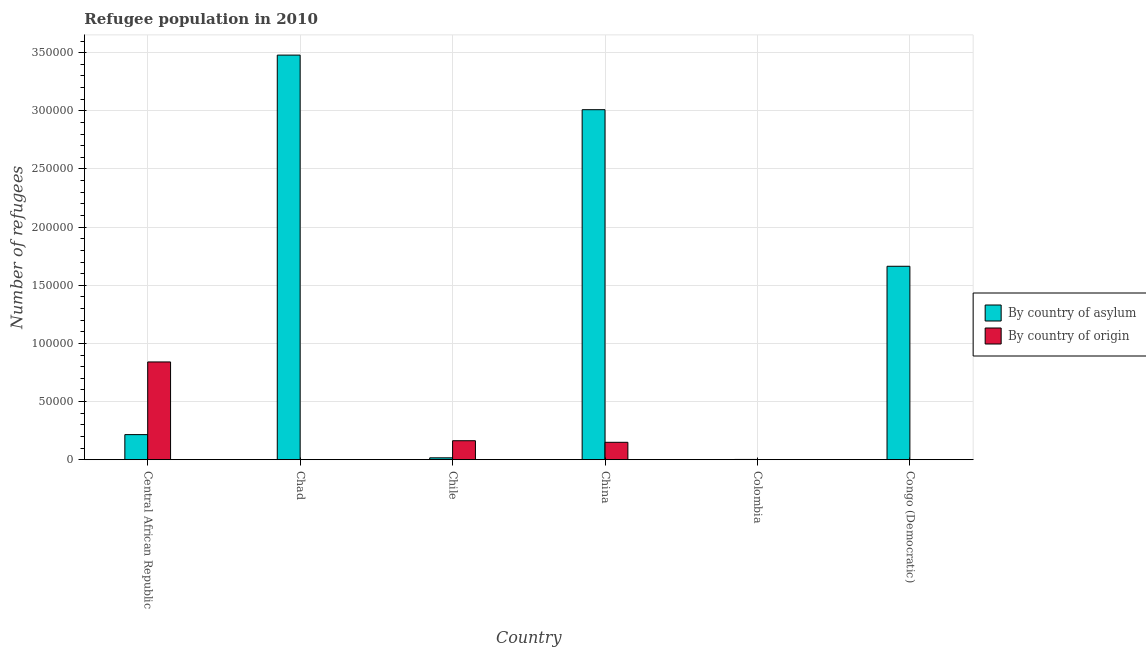How many different coloured bars are there?
Give a very brief answer. 2. What is the label of the 6th group of bars from the left?
Provide a succinct answer. Congo (Democratic). In how many cases, is the number of bars for a given country not equal to the number of legend labels?
Make the answer very short. 0. What is the number of refugees by country of asylum in China?
Your answer should be compact. 3.01e+05. Across all countries, what is the maximum number of refugees by country of asylum?
Your answer should be compact. 3.48e+05. Across all countries, what is the minimum number of refugees by country of asylum?
Your answer should be compact. 212. In which country was the number of refugees by country of origin maximum?
Offer a very short reply. Central African Republic. In which country was the number of refugees by country of origin minimum?
Offer a very short reply. Congo (Democratic). What is the total number of refugees by country of asylum in the graph?
Your answer should be very brief. 8.39e+05. What is the difference between the number of refugees by country of origin in Central African Republic and that in Chad?
Give a very brief answer. 8.40e+04. What is the difference between the number of refugees by country of asylum in China and the number of refugees by country of origin in Chad?
Offer a very short reply. 3.01e+05. What is the average number of refugees by country of origin per country?
Your answer should be compact. 1.92e+04. What is the difference between the number of refugees by country of origin and number of refugees by country of asylum in Colombia?
Give a very brief answer. -122. In how many countries, is the number of refugees by country of asylum greater than 340000 ?
Offer a terse response. 1. What is the ratio of the number of refugees by country of asylum in Central African Republic to that in Congo (Democratic)?
Your answer should be very brief. 0.13. Is the number of refugees by country of origin in Central African Republic less than that in Chad?
Provide a succinct answer. No. Is the difference between the number of refugees by country of asylum in Chad and China greater than the difference between the number of refugees by country of origin in Chad and China?
Give a very brief answer. Yes. What is the difference between the highest and the second highest number of refugees by country of asylum?
Offer a terse response. 4.70e+04. What is the difference between the highest and the lowest number of refugees by country of origin?
Your answer should be compact. 8.41e+04. In how many countries, is the number of refugees by country of asylum greater than the average number of refugees by country of asylum taken over all countries?
Make the answer very short. 3. What does the 1st bar from the left in Colombia represents?
Ensure brevity in your answer.  By country of asylum. What does the 2nd bar from the right in Chad represents?
Provide a short and direct response. By country of asylum. How many bars are there?
Your answer should be very brief. 12. What is the difference between two consecutive major ticks on the Y-axis?
Provide a short and direct response. 5.00e+04. How many legend labels are there?
Your response must be concise. 2. How are the legend labels stacked?
Give a very brief answer. Vertical. What is the title of the graph?
Provide a short and direct response. Refugee population in 2010. Does "Official aid received" appear as one of the legend labels in the graph?
Offer a terse response. No. What is the label or title of the X-axis?
Make the answer very short. Country. What is the label or title of the Y-axis?
Keep it short and to the point. Number of refugees. What is the Number of refugees of By country of asylum in Central African Republic?
Provide a succinct answer. 2.16e+04. What is the Number of refugees of By country of origin in Central African Republic?
Offer a terse response. 8.41e+04. What is the Number of refugees of By country of asylum in Chad?
Offer a terse response. 3.48e+05. What is the Number of refugees in By country of origin in Chad?
Make the answer very short. 25. What is the Number of refugees of By country of asylum in Chile?
Offer a very short reply. 1621. What is the Number of refugees in By country of origin in Chile?
Keep it short and to the point. 1.63e+04. What is the Number of refugees in By country of asylum in China?
Offer a very short reply. 3.01e+05. What is the Number of refugees in By country of origin in China?
Ensure brevity in your answer.  1.50e+04. What is the Number of refugees in By country of asylum in Colombia?
Keep it short and to the point. 212. What is the Number of refugees in By country of asylum in Congo (Democratic)?
Ensure brevity in your answer.  1.66e+05. What is the Number of refugees of By country of origin in Congo (Democratic)?
Provide a succinct answer. 1. Across all countries, what is the maximum Number of refugees in By country of asylum?
Provide a succinct answer. 3.48e+05. Across all countries, what is the maximum Number of refugees of By country of origin?
Offer a very short reply. 8.41e+04. Across all countries, what is the minimum Number of refugees of By country of asylum?
Provide a succinct answer. 212. Across all countries, what is the minimum Number of refugees of By country of origin?
Keep it short and to the point. 1. What is the total Number of refugees in By country of asylum in the graph?
Give a very brief answer. 8.39e+05. What is the total Number of refugees of By country of origin in the graph?
Keep it short and to the point. 1.15e+05. What is the difference between the Number of refugees in By country of asylum in Central African Republic and that in Chad?
Your answer should be very brief. -3.26e+05. What is the difference between the Number of refugees in By country of origin in Central African Republic and that in Chad?
Your answer should be very brief. 8.40e+04. What is the difference between the Number of refugees in By country of asylum in Central African Republic and that in Chile?
Your answer should be very brief. 2.00e+04. What is the difference between the Number of refugees of By country of origin in Central African Republic and that in Chile?
Offer a very short reply. 6.78e+04. What is the difference between the Number of refugees of By country of asylum in Central African Republic and that in China?
Provide a succinct answer. -2.79e+05. What is the difference between the Number of refugees of By country of origin in Central African Republic and that in China?
Ensure brevity in your answer.  6.91e+04. What is the difference between the Number of refugees of By country of asylum in Central African Republic and that in Colombia?
Make the answer very short. 2.14e+04. What is the difference between the Number of refugees of By country of origin in Central African Republic and that in Colombia?
Your answer should be very brief. 8.40e+04. What is the difference between the Number of refugees in By country of asylum in Central African Republic and that in Congo (Democratic)?
Give a very brief answer. -1.45e+05. What is the difference between the Number of refugees of By country of origin in Central African Republic and that in Congo (Democratic)?
Offer a very short reply. 8.41e+04. What is the difference between the Number of refugees in By country of asylum in Chad and that in Chile?
Your answer should be compact. 3.46e+05. What is the difference between the Number of refugees of By country of origin in Chad and that in Chile?
Keep it short and to the point. -1.63e+04. What is the difference between the Number of refugees in By country of asylum in Chad and that in China?
Offer a terse response. 4.70e+04. What is the difference between the Number of refugees in By country of origin in Chad and that in China?
Offer a very short reply. -1.49e+04. What is the difference between the Number of refugees in By country of asylum in Chad and that in Colombia?
Make the answer very short. 3.48e+05. What is the difference between the Number of refugees in By country of origin in Chad and that in Colombia?
Your answer should be compact. -65. What is the difference between the Number of refugees in By country of asylum in Chad and that in Congo (Democratic)?
Your answer should be compact. 1.82e+05. What is the difference between the Number of refugees in By country of asylum in Chile and that in China?
Make the answer very short. -2.99e+05. What is the difference between the Number of refugees of By country of origin in Chile and that in China?
Keep it short and to the point. 1351. What is the difference between the Number of refugees of By country of asylum in Chile and that in Colombia?
Ensure brevity in your answer.  1409. What is the difference between the Number of refugees in By country of origin in Chile and that in Colombia?
Make the answer very short. 1.62e+04. What is the difference between the Number of refugees of By country of asylum in Chile and that in Congo (Democratic)?
Offer a terse response. -1.65e+05. What is the difference between the Number of refugees in By country of origin in Chile and that in Congo (Democratic)?
Give a very brief answer. 1.63e+04. What is the difference between the Number of refugees of By country of asylum in China and that in Colombia?
Ensure brevity in your answer.  3.01e+05. What is the difference between the Number of refugees in By country of origin in China and that in Colombia?
Offer a very short reply. 1.49e+04. What is the difference between the Number of refugees in By country of asylum in China and that in Congo (Democratic)?
Make the answer very short. 1.35e+05. What is the difference between the Number of refugees in By country of origin in China and that in Congo (Democratic)?
Ensure brevity in your answer.  1.50e+04. What is the difference between the Number of refugees of By country of asylum in Colombia and that in Congo (Democratic)?
Give a very brief answer. -1.66e+05. What is the difference between the Number of refugees in By country of origin in Colombia and that in Congo (Democratic)?
Provide a succinct answer. 89. What is the difference between the Number of refugees of By country of asylum in Central African Republic and the Number of refugees of By country of origin in Chad?
Offer a very short reply. 2.15e+04. What is the difference between the Number of refugees in By country of asylum in Central African Republic and the Number of refugees in By country of origin in Chile?
Offer a terse response. 5260. What is the difference between the Number of refugees in By country of asylum in Central African Republic and the Number of refugees in By country of origin in China?
Your response must be concise. 6611. What is the difference between the Number of refugees of By country of asylum in Central African Republic and the Number of refugees of By country of origin in Colombia?
Ensure brevity in your answer.  2.15e+04. What is the difference between the Number of refugees in By country of asylum in Central African Republic and the Number of refugees in By country of origin in Congo (Democratic)?
Offer a very short reply. 2.16e+04. What is the difference between the Number of refugees in By country of asylum in Chad and the Number of refugees in By country of origin in Chile?
Your answer should be compact. 3.32e+05. What is the difference between the Number of refugees of By country of asylum in Chad and the Number of refugees of By country of origin in China?
Ensure brevity in your answer.  3.33e+05. What is the difference between the Number of refugees of By country of asylum in Chad and the Number of refugees of By country of origin in Colombia?
Ensure brevity in your answer.  3.48e+05. What is the difference between the Number of refugees in By country of asylum in Chad and the Number of refugees in By country of origin in Congo (Democratic)?
Offer a very short reply. 3.48e+05. What is the difference between the Number of refugees of By country of asylum in Chile and the Number of refugees of By country of origin in China?
Keep it short and to the point. -1.33e+04. What is the difference between the Number of refugees in By country of asylum in Chile and the Number of refugees in By country of origin in Colombia?
Provide a succinct answer. 1531. What is the difference between the Number of refugees in By country of asylum in Chile and the Number of refugees in By country of origin in Congo (Democratic)?
Provide a succinct answer. 1620. What is the difference between the Number of refugees of By country of asylum in China and the Number of refugees of By country of origin in Colombia?
Make the answer very short. 3.01e+05. What is the difference between the Number of refugees of By country of asylum in China and the Number of refugees of By country of origin in Congo (Democratic)?
Make the answer very short. 3.01e+05. What is the difference between the Number of refugees in By country of asylum in Colombia and the Number of refugees in By country of origin in Congo (Democratic)?
Keep it short and to the point. 211. What is the average Number of refugees of By country of asylum per country?
Your answer should be very brief. 1.40e+05. What is the average Number of refugees in By country of origin per country?
Provide a short and direct response. 1.92e+04. What is the difference between the Number of refugees of By country of asylum and Number of refugees of By country of origin in Central African Republic?
Provide a succinct answer. -6.25e+04. What is the difference between the Number of refugees in By country of asylum and Number of refugees in By country of origin in Chad?
Offer a terse response. 3.48e+05. What is the difference between the Number of refugees in By country of asylum and Number of refugees in By country of origin in Chile?
Offer a terse response. -1.47e+04. What is the difference between the Number of refugees of By country of asylum and Number of refugees of By country of origin in China?
Give a very brief answer. 2.86e+05. What is the difference between the Number of refugees in By country of asylum and Number of refugees in By country of origin in Colombia?
Make the answer very short. 122. What is the difference between the Number of refugees of By country of asylum and Number of refugees of By country of origin in Congo (Democratic)?
Provide a short and direct response. 1.66e+05. What is the ratio of the Number of refugees of By country of asylum in Central African Republic to that in Chad?
Provide a succinct answer. 0.06. What is the ratio of the Number of refugees of By country of origin in Central African Republic to that in Chad?
Keep it short and to the point. 3362.56. What is the ratio of the Number of refugees in By country of asylum in Central African Republic to that in Chile?
Offer a terse response. 13.31. What is the ratio of the Number of refugees in By country of origin in Central African Republic to that in Chile?
Provide a succinct answer. 5.15. What is the ratio of the Number of refugees in By country of asylum in Central African Republic to that in China?
Your answer should be very brief. 0.07. What is the ratio of the Number of refugees of By country of origin in Central African Republic to that in China?
Your response must be concise. 5.62. What is the ratio of the Number of refugees in By country of asylum in Central African Republic to that in Colombia?
Offer a terse response. 101.76. What is the ratio of the Number of refugees of By country of origin in Central African Republic to that in Colombia?
Make the answer very short. 934.04. What is the ratio of the Number of refugees in By country of asylum in Central African Republic to that in Congo (Democratic)?
Make the answer very short. 0.13. What is the ratio of the Number of refugees in By country of origin in Central African Republic to that in Congo (Democratic)?
Offer a terse response. 8.41e+04. What is the ratio of the Number of refugees in By country of asylum in Chad to that in Chile?
Give a very brief answer. 214.64. What is the ratio of the Number of refugees in By country of origin in Chad to that in Chile?
Offer a terse response. 0. What is the ratio of the Number of refugees of By country of asylum in Chad to that in China?
Make the answer very short. 1.16. What is the ratio of the Number of refugees in By country of origin in Chad to that in China?
Offer a terse response. 0. What is the ratio of the Number of refugees of By country of asylum in Chad to that in Colombia?
Offer a terse response. 1641.22. What is the ratio of the Number of refugees of By country of origin in Chad to that in Colombia?
Your response must be concise. 0.28. What is the ratio of the Number of refugees in By country of asylum in Chad to that in Congo (Democratic)?
Give a very brief answer. 2.09. What is the ratio of the Number of refugees in By country of asylum in Chile to that in China?
Ensure brevity in your answer.  0.01. What is the ratio of the Number of refugees of By country of origin in Chile to that in China?
Your answer should be very brief. 1.09. What is the ratio of the Number of refugees in By country of asylum in Chile to that in Colombia?
Your answer should be very brief. 7.65. What is the ratio of the Number of refugees in By country of origin in Chile to that in Colombia?
Offer a very short reply. 181.27. What is the ratio of the Number of refugees of By country of asylum in Chile to that in Congo (Democratic)?
Your answer should be compact. 0.01. What is the ratio of the Number of refugees of By country of origin in Chile to that in Congo (Democratic)?
Provide a short and direct response. 1.63e+04. What is the ratio of the Number of refugees in By country of asylum in China to that in Colombia?
Keep it short and to the point. 1419.75. What is the ratio of the Number of refugees of By country of origin in China to that in Colombia?
Provide a short and direct response. 166.26. What is the ratio of the Number of refugees of By country of asylum in China to that in Congo (Democratic)?
Keep it short and to the point. 1.81. What is the ratio of the Number of refugees in By country of origin in China to that in Congo (Democratic)?
Make the answer very short. 1.50e+04. What is the ratio of the Number of refugees in By country of asylum in Colombia to that in Congo (Democratic)?
Provide a succinct answer. 0. What is the ratio of the Number of refugees of By country of origin in Colombia to that in Congo (Democratic)?
Provide a succinct answer. 90. What is the difference between the highest and the second highest Number of refugees in By country of asylum?
Ensure brevity in your answer.  4.70e+04. What is the difference between the highest and the second highest Number of refugees of By country of origin?
Provide a succinct answer. 6.78e+04. What is the difference between the highest and the lowest Number of refugees of By country of asylum?
Keep it short and to the point. 3.48e+05. What is the difference between the highest and the lowest Number of refugees in By country of origin?
Provide a succinct answer. 8.41e+04. 